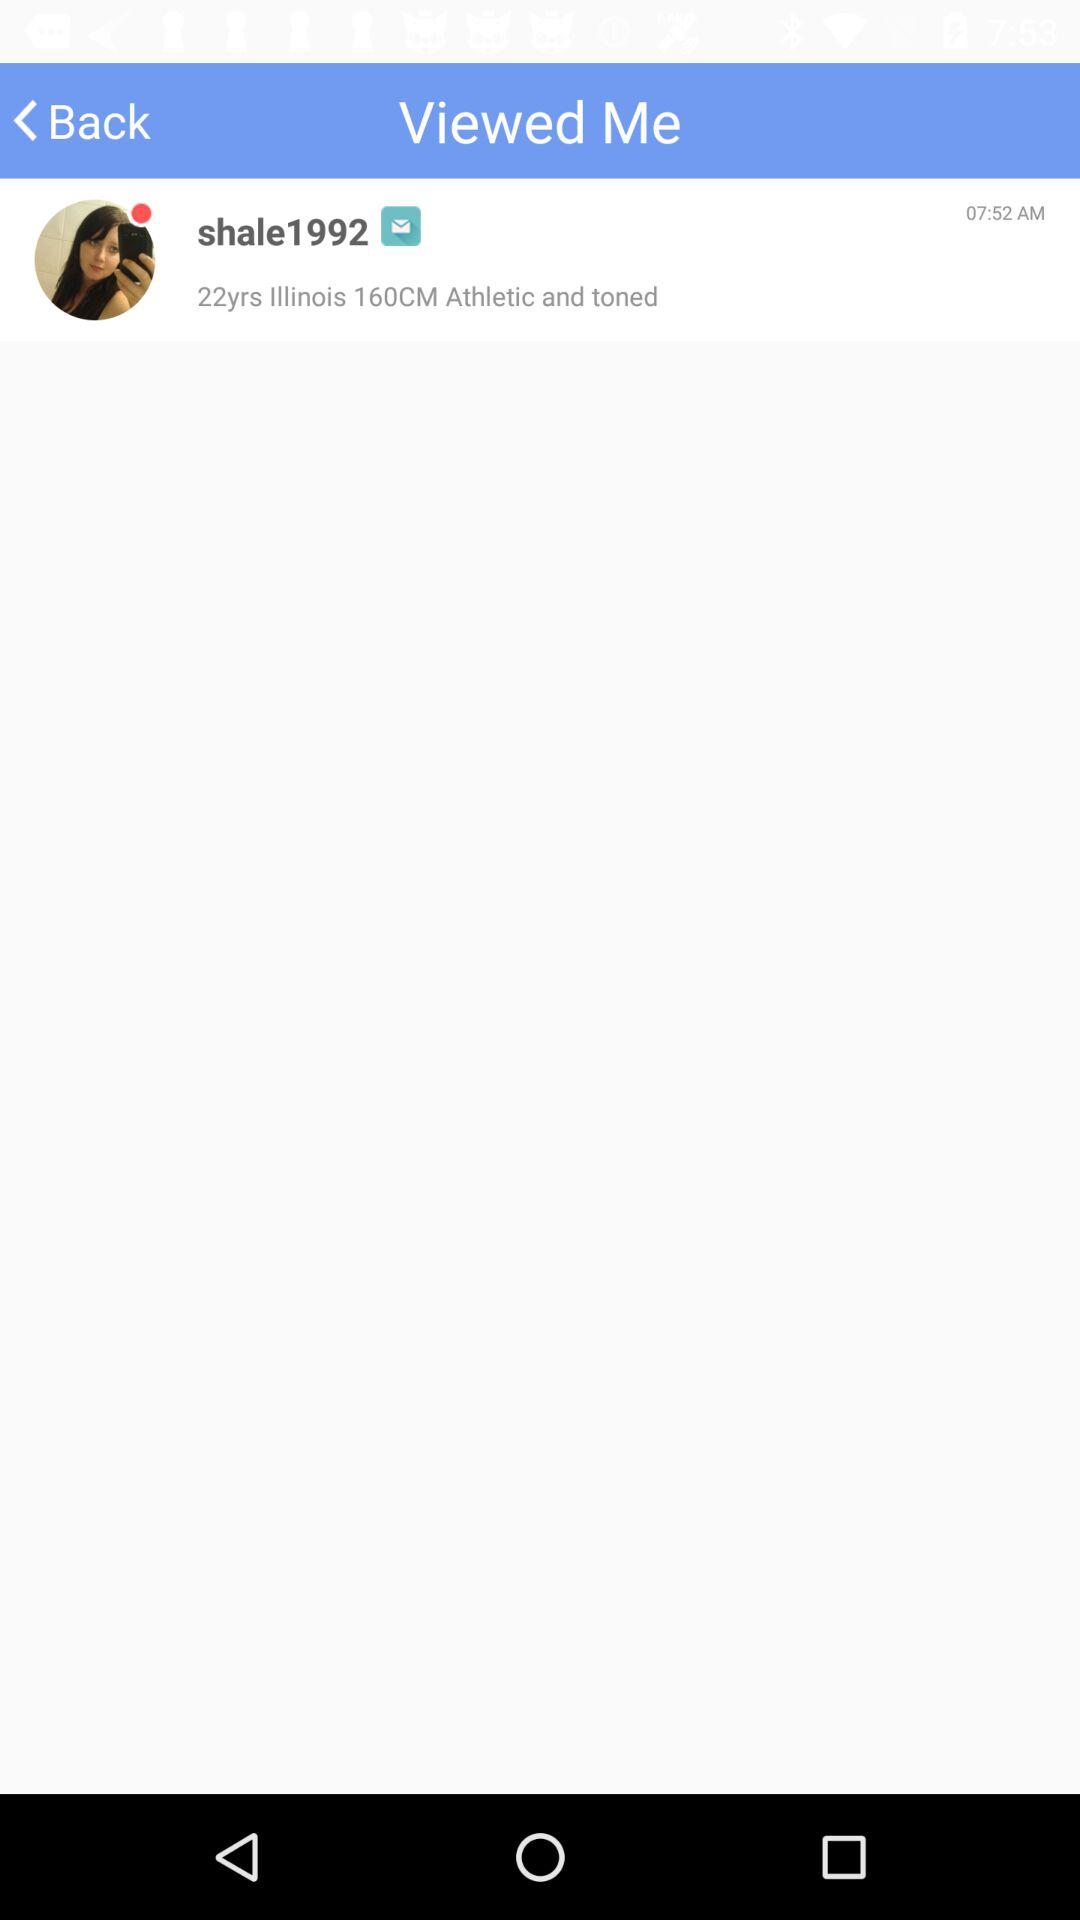What is the username? The username is "shale1992". 